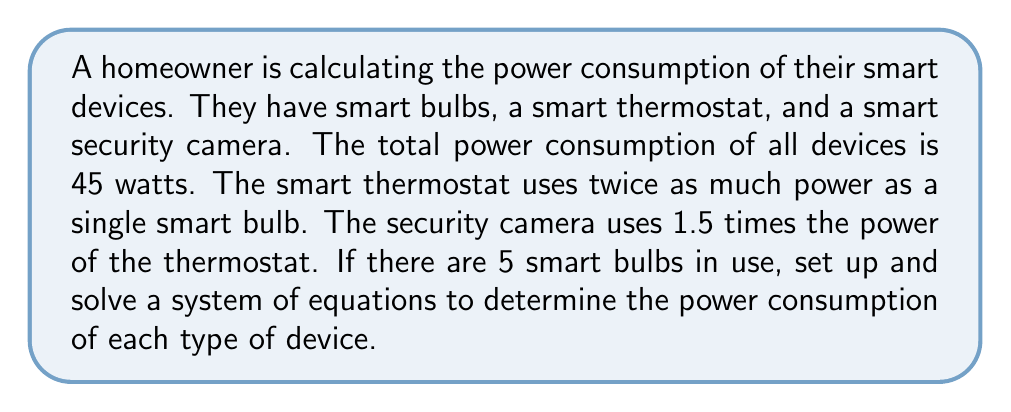Help me with this question. Let's define our variables:
$x$ = power consumption of one smart bulb (in watts)
$y$ = power consumption of the smart thermostat (in watts)
$z$ = power consumption of the smart security camera (in watts)

Now, we can set up our system of equations based on the given information:

1. Total power consumption equation:
   $$5x + y + z = 45$$

2. Thermostat power consumption relative to a smart bulb:
   $$y = 2x$$

3. Security camera power consumption relative to the thermostat:
   $$z = 1.5y$$

Let's solve this system by substitution:

Step 1: Substitute equation 2 into equation 3:
$$z = 1.5(2x) = 3x$$

Step 2: Substitute equations 2 and 3 into equation 1:
$$5x + 2x + 3x = 45$$
$$10x = 45$$

Step 3: Solve for x:
$$x = 4.5$$

Step 4: Calculate y using equation 2:
$$y = 2x = 2(4.5) = 9$$

Step 5: Calculate z using equation 3:
$$z = 1.5y = 1.5(9) = 13.5$$

Therefore, the power consumption of each device is:
- Smart bulb: 4.5 watts
- Smart thermostat: 9 watts
- Smart security camera: 13.5 watts
Answer: Smart bulb: 4.5W, Thermostat: 9W, Camera: 13.5W 